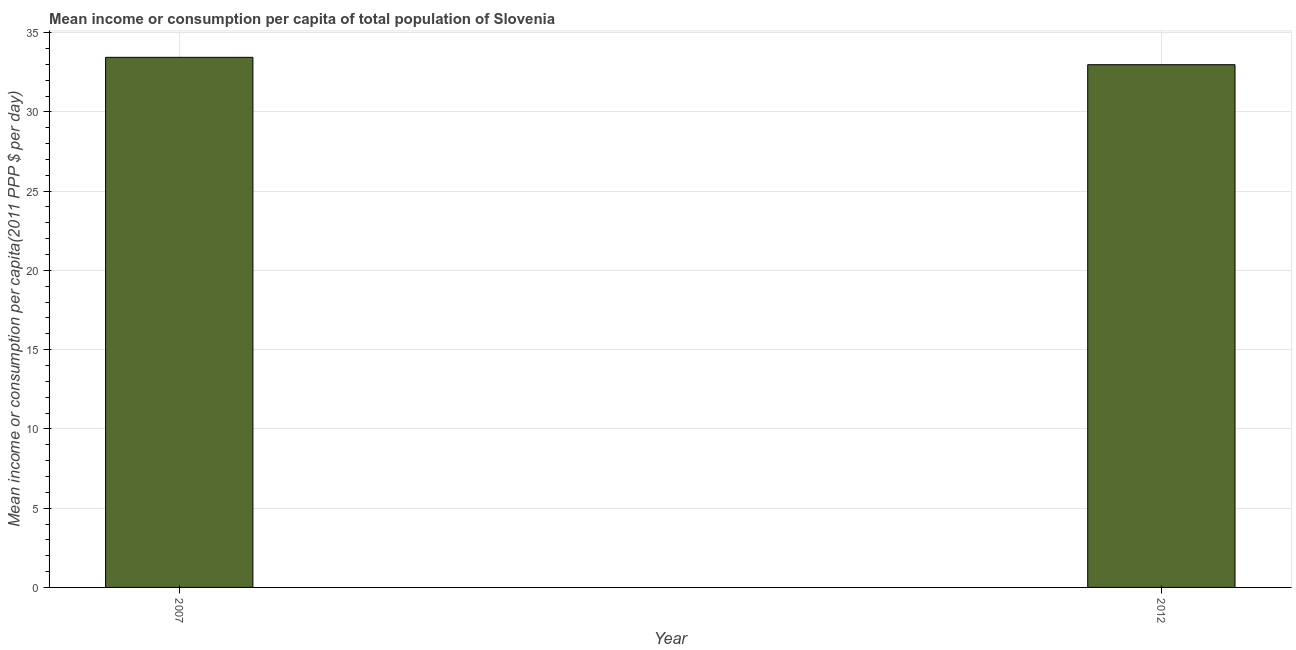What is the title of the graph?
Give a very brief answer. Mean income or consumption per capita of total population of Slovenia. What is the label or title of the X-axis?
Your answer should be very brief. Year. What is the label or title of the Y-axis?
Your response must be concise. Mean income or consumption per capita(2011 PPP $ per day). What is the mean income or consumption in 2007?
Provide a short and direct response. 33.44. Across all years, what is the maximum mean income or consumption?
Make the answer very short. 33.44. Across all years, what is the minimum mean income or consumption?
Make the answer very short. 32.97. In which year was the mean income or consumption minimum?
Provide a succinct answer. 2012. What is the sum of the mean income or consumption?
Your response must be concise. 66.41. What is the difference between the mean income or consumption in 2007 and 2012?
Offer a very short reply. 0.47. What is the average mean income or consumption per year?
Make the answer very short. 33.21. What is the median mean income or consumption?
Your answer should be very brief. 33.21. In how many years, is the mean income or consumption greater than 27 $?
Your answer should be very brief. 2. What is the ratio of the mean income or consumption in 2007 to that in 2012?
Your answer should be very brief. 1.01. Is the mean income or consumption in 2007 less than that in 2012?
Provide a succinct answer. No. Are all the bars in the graph horizontal?
Keep it short and to the point. No. How many years are there in the graph?
Provide a succinct answer. 2. What is the difference between two consecutive major ticks on the Y-axis?
Your answer should be very brief. 5. What is the Mean income or consumption per capita(2011 PPP $ per day) in 2007?
Your answer should be compact. 33.44. What is the Mean income or consumption per capita(2011 PPP $ per day) in 2012?
Keep it short and to the point. 32.97. What is the difference between the Mean income or consumption per capita(2011 PPP $ per day) in 2007 and 2012?
Provide a short and direct response. 0.47. 